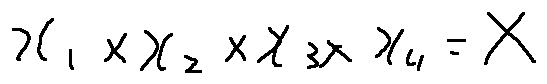<formula> <loc_0><loc_0><loc_500><loc_500>x _ { 1 } \times x _ { 2 } \times x _ { 3 } \times x _ { 4 } = X</formula> 